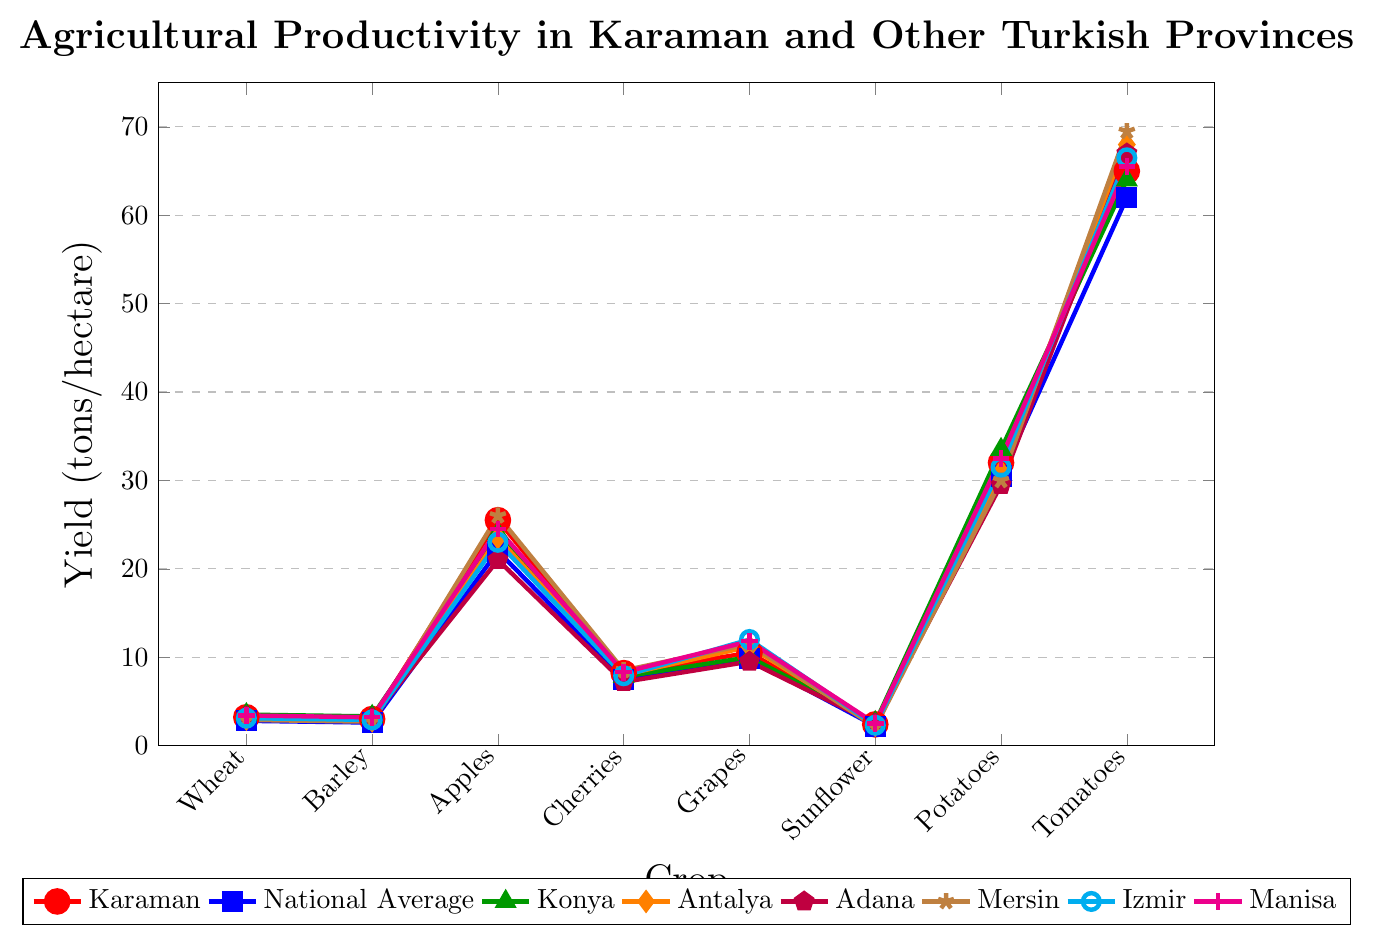What is the yield of tomatoes in Karaman? The figure shows a dot plot with different crop yields. Look at the dot corresponding to tomatoes for the red line labeled "Karaman." The yield is 65 tons/hectare.
Answer: 65 tons/hectare Which province has the highest yield for grapes? Compare the heights of the dots representing grape yields across all provinces. The cyan dot for Izmir is the highest, representing a yield of 12 tons/hectare.
Answer: Izmir How does Karaman's yield of apples compare to the national average? Look at the red dot for Karaman and the blue dot for the national average for apples. Karaman's yield (25.5 tons/hectare) is higher than the national average (22 tons/hectare).
Answer: Higher What is the difference in potato yield between Karaman and Konya? Locate the dots for potatoes for both Karaman (red) and Konya (green). Subtract Konya's yield (33.5) from Karaman's yield (32.0).
Answer: 1.5 tons/hectare Which crop has the smallest yield difference between Karaman and the national average? Calculate the absolute differences for each crop between Karaman and the national average, then identify the smallest difference. The smallest difference is for Sunflower, with a difference of (2.4 - 2.2) = 0.2 tons/hectare.
Answer: Sunflower How many crops have a higher yield in Mersin compared to Karaman? Compare the yields of each crop in Mersin (brown) to those in Karaman (red). The crops where Mersin's yield is higher are: Apples, Cherries, Grapes, and Tomatoes. There are 4 such crops.
Answer: 4 crops What is the average yield of cherries across all provinces? Sum the cherry yields of Karaman, Konya, Antalya, Adana, Mersin, Izmir, and Manisa, and divide by the number of provinces. The sum is \(8.2 + 7.8 + 8.0 + 7.2 + 8.5 + 7.9 + 8.3\) = 56.9. The number of provinces is 7, so the average is \(56.9 / 7 \approx 8.13\) tons/hectare.
Answer: 8.13 tons/hectare Which crop shows Karaman leading in yield compared to all other provinces? For each crop, identify if Karaman's yield is the highest among all provinces. Compare visually and determine that Sunflower shows Karaman leading with 2.4 tons/hectare over all other provinces.
Answer: Sunflower What is the combined yield of wheat and barley in Karaman? Find the yields of wheat and barley in Karaman, which are 3.2 tons/hectare and 3.0 tons/hectare, respectively. Add these yields: \(3.2 + 3.0 = 6.2\) tons/hectare.
Answer: 6.2 tons/hectare 